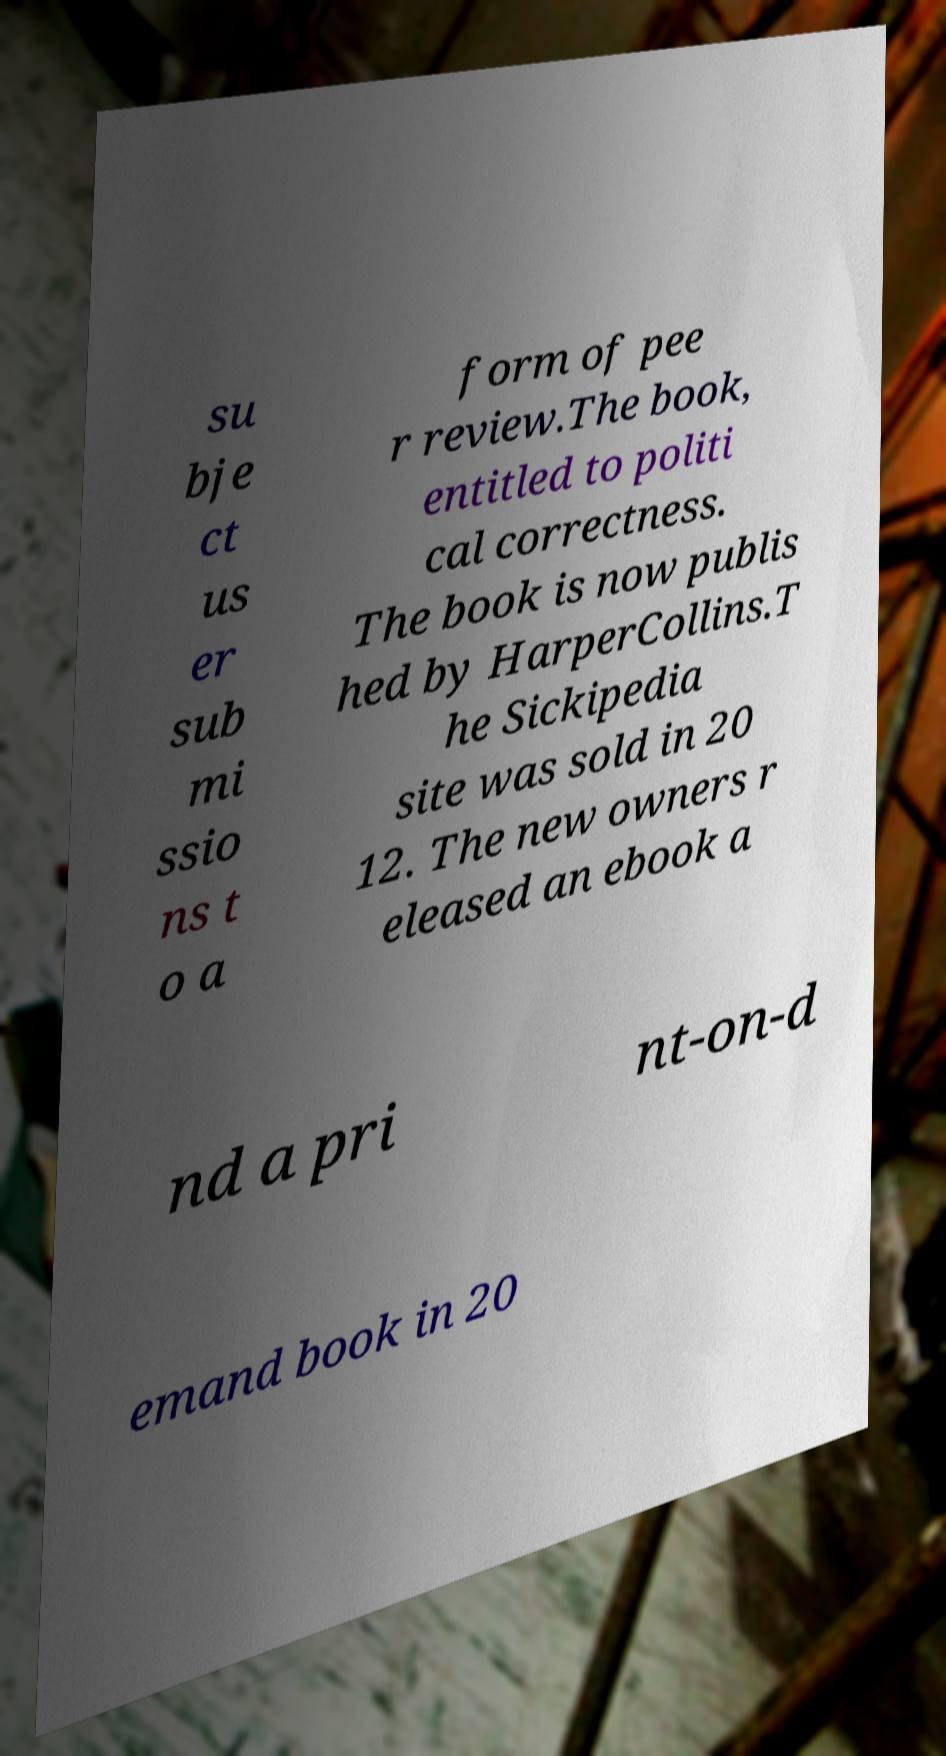Can you read and provide the text displayed in the image?This photo seems to have some interesting text. Can you extract and type it out for me? su bje ct us er sub mi ssio ns t o a form of pee r review.The book, entitled to politi cal correctness. The book is now publis hed by HarperCollins.T he Sickipedia site was sold in 20 12. The new owners r eleased an ebook a nd a pri nt-on-d emand book in 20 